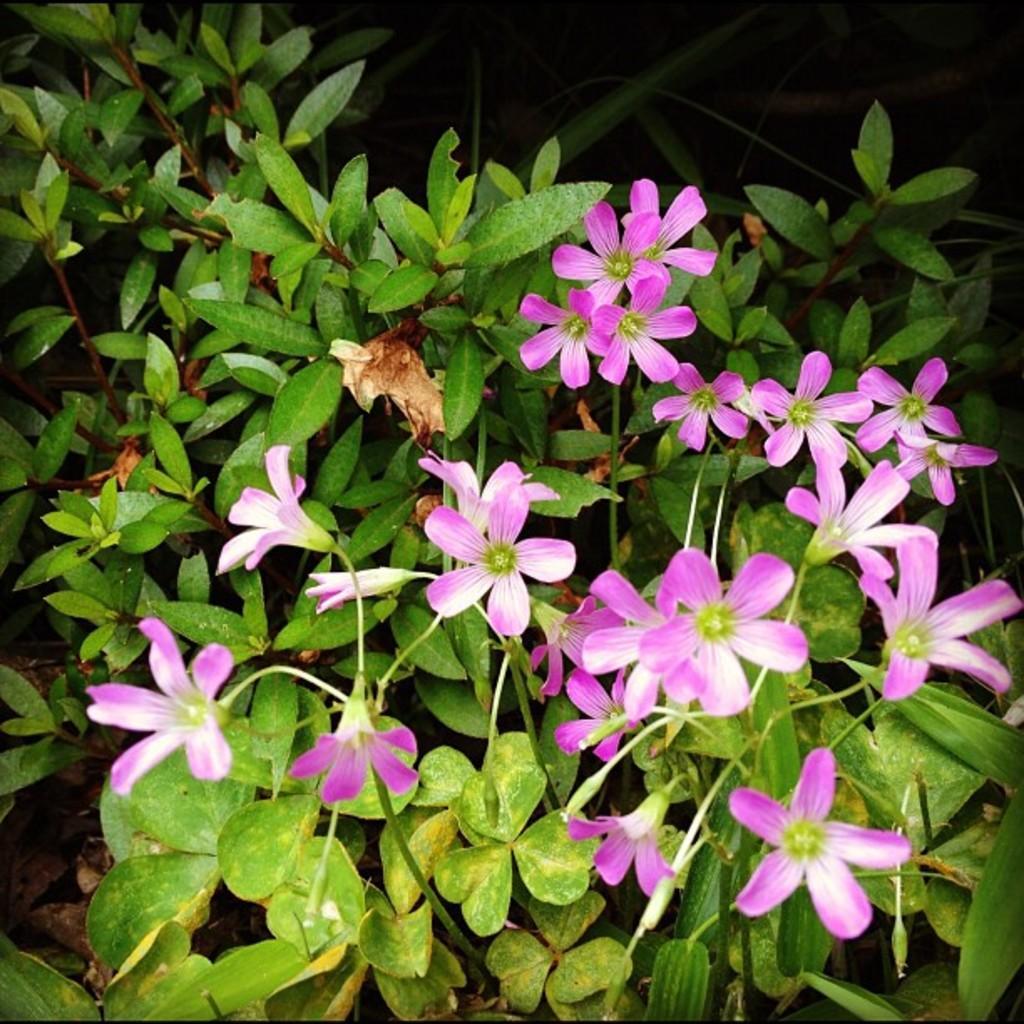How would you summarize this image in a sentence or two? In the image in the center, we can see plants and flowers, which are in pink and white color. 